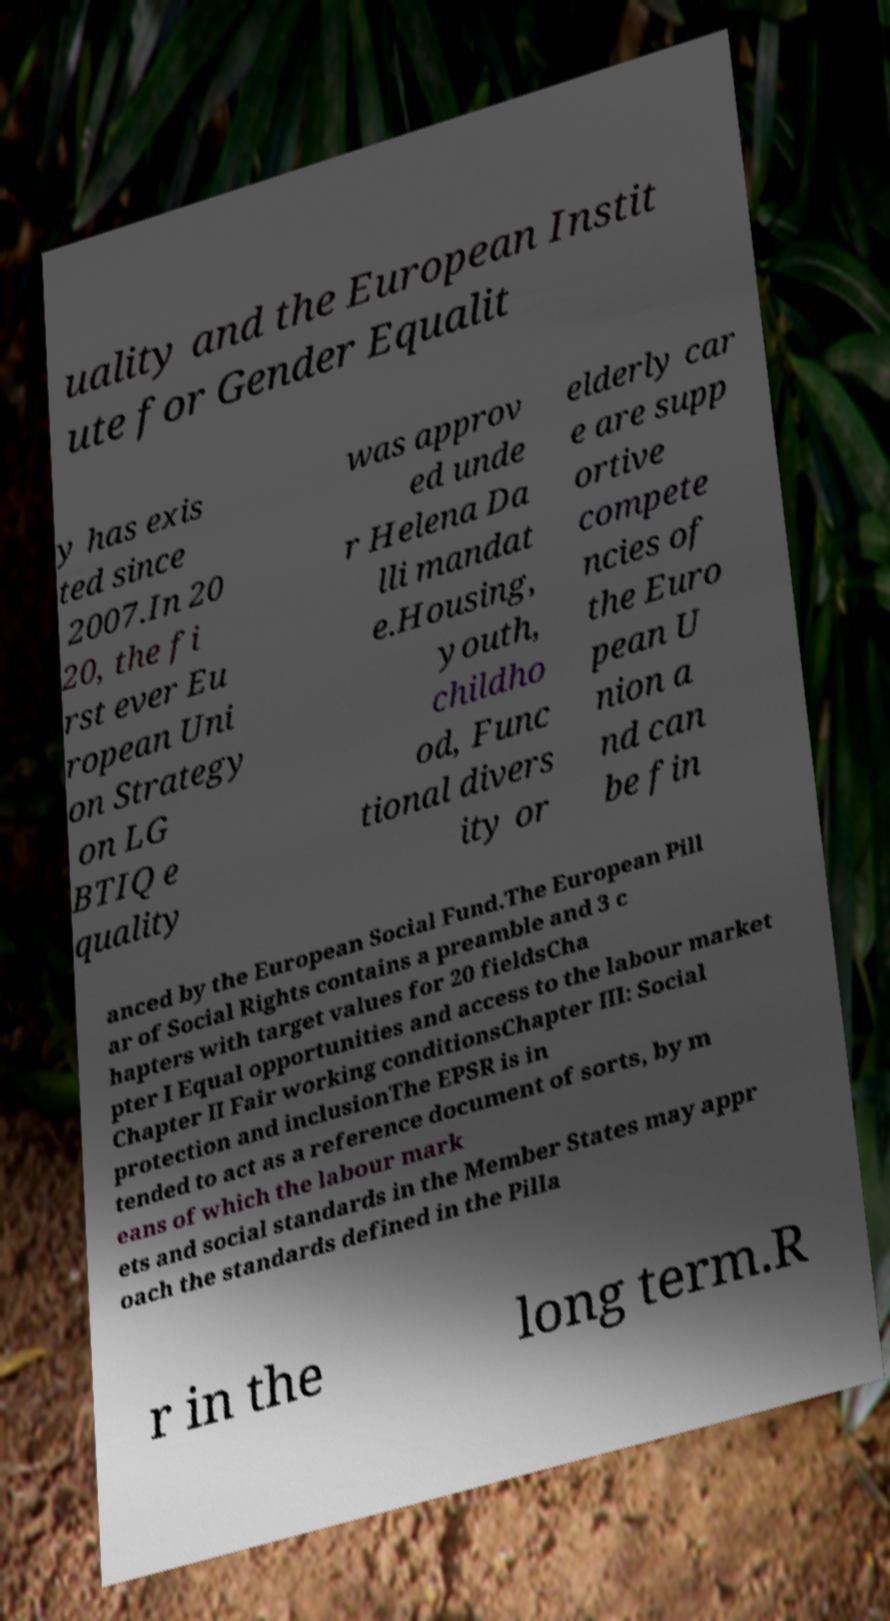Can you accurately transcribe the text from the provided image for me? uality and the European Instit ute for Gender Equalit y has exis ted since 2007.In 20 20, the fi rst ever Eu ropean Uni on Strategy on LG BTIQ e quality was approv ed unde r Helena Da lli mandat e.Housing, youth, childho od, Func tional divers ity or elderly car e are supp ortive compete ncies of the Euro pean U nion a nd can be fin anced by the European Social Fund.The European Pill ar of Social Rights contains a preamble and 3 c hapters with target values for 20 fieldsCha pter I Equal opportunities and access to the labour market Chapter II Fair working conditionsChapter III: Social protection and inclusionThe EPSR is in tended to act as a reference document of sorts, by m eans of which the labour mark ets and social standards in the Member States may appr oach the standards defined in the Pilla r in the long term.R 